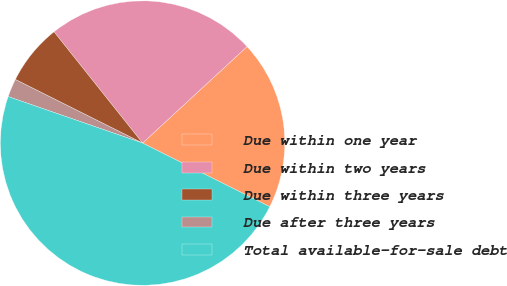<chart> <loc_0><loc_0><loc_500><loc_500><pie_chart><fcel>Due within one year<fcel>Due within two years<fcel>Due within three years<fcel>Due after three years<fcel>Total available-for-sale debt<nl><fcel>19.25%<fcel>23.83%<fcel>6.92%<fcel>2.08%<fcel>47.91%<nl></chart> 